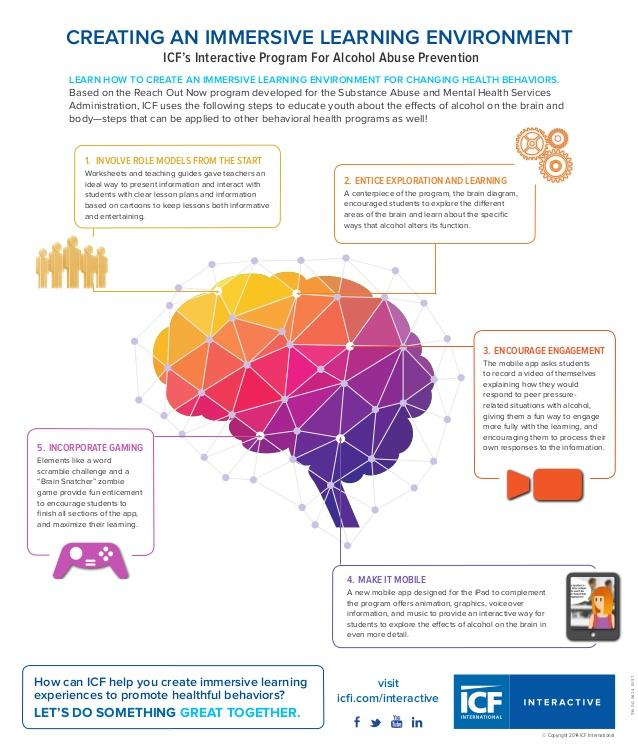Draw attention to some important aspects in this diagram. The color orange was previously used to represent the concept of "Encourage Engagement. The color that was previously used to represent "Incorporate Gaming" is violet. 